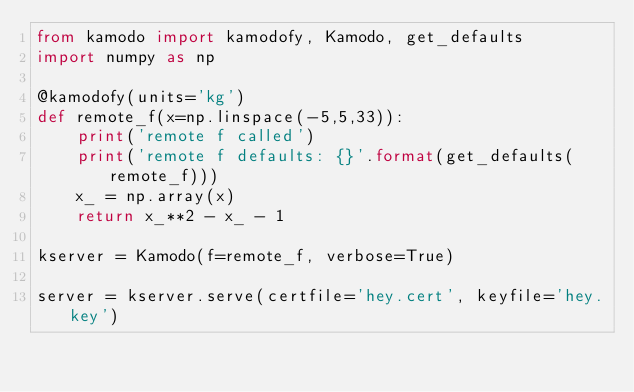<code> <loc_0><loc_0><loc_500><loc_500><_Python_>from kamodo import kamodofy, Kamodo, get_defaults
import numpy as np

@kamodofy(units='kg')
def remote_f(x=np.linspace(-5,5,33)):
    print('remote f called')
    print('remote f defaults: {}'.format(get_defaults(remote_f)))
    x_ = np.array(x)
    return x_**2 - x_ - 1

kserver = Kamodo(f=remote_f, verbose=True)

server = kserver.serve(certfile='hey.cert', keyfile='hey.key')
</code> 